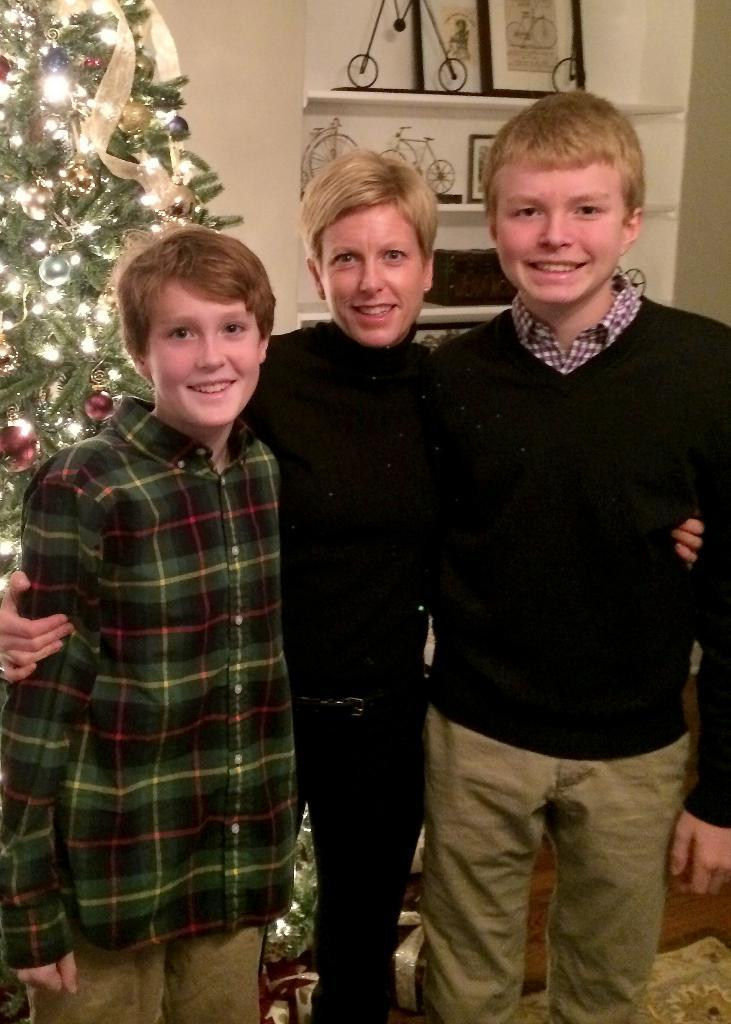How many people are standing in the image? There are three people standing in the image. What can be seen in the background of the image? There is a Christmas tree with lights, a wall, frames, and objects on shelves in the background. What is the rate of the page turning in the image? There is no page turning in the image, as it features people standing and a background with a Christmas tree, wall, frames, and objects on shelves. 